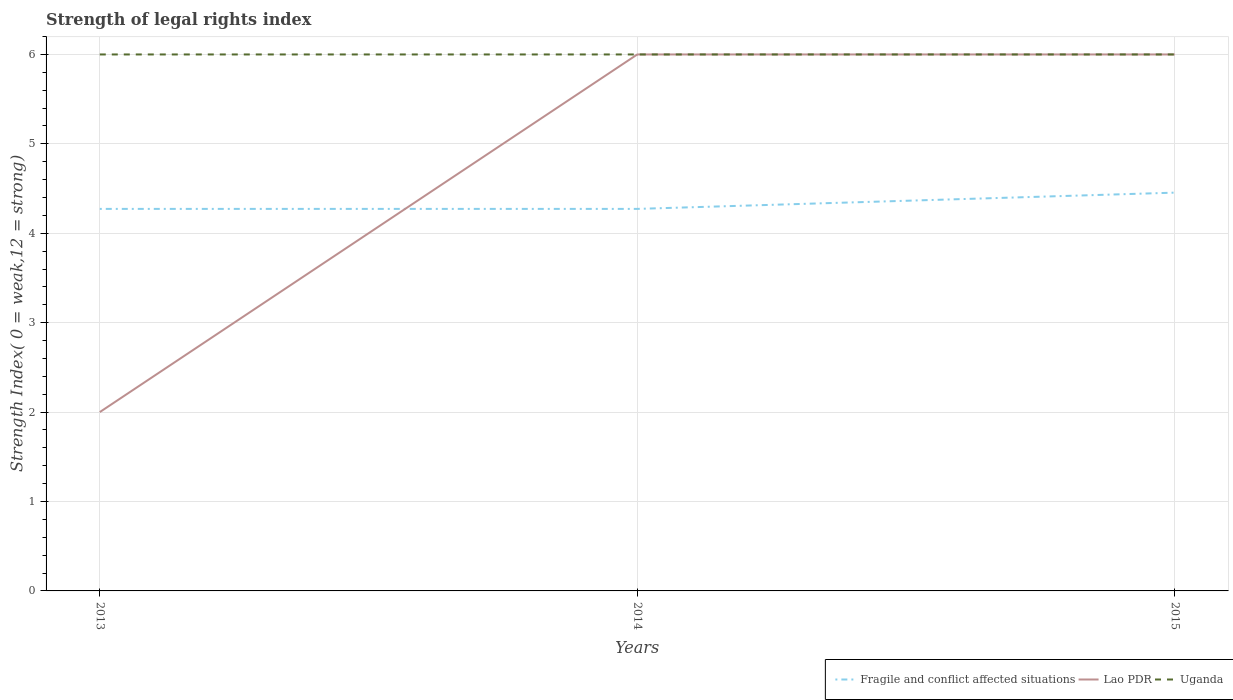Is the number of lines equal to the number of legend labels?
Your answer should be compact. Yes. Across all years, what is the maximum strength index in Fragile and conflict affected situations?
Your answer should be compact. 4.27. What is the difference between the highest and the second highest strength index in Lao PDR?
Ensure brevity in your answer.  4. What is the difference between the highest and the lowest strength index in Fragile and conflict affected situations?
Offer a very short reply. 1. How many legend labels are there?
Your answer should be very brief. 3. How are the legend labels stacked?
Provide a short and direct response. Horizontal. What is the title of the graph?
Offer a very short reply. Strength of legal rights index. What is the label or title of the Y-axis?
Make the answer very short. Strength Index( 0 = weak,12 = strong). What is the Strength Index( 0 = weak,12 = strong) of Fragile and conflict affected situations in 2013?
Make the answer very short. 4.27. What is the Strength Index( 0 = weak,12 = strong) in Fragile and conflict affected situations in 2014?
Offer a terse response. 4.27. What is the Strength Index( 0 = weak,12 = strong) in Lao PDR in 2014?
Keep it short and to the point. 6. What is the Strength Index( 0 = weak,12 = strong) of Fragile and conflict affected situations in 2015?
Offer a terse response. 4.45. Across all years, what is the maximum Strength Index( 0 = weak,12 = strong) of Fragile and conflict affected situations?
Offer a very short reply. 4.45. Across all years, what is the minimum Strength Index( 0 = weak,12 = strong) of Fragile and conflict affected situations?
Ensure brevity in your answer.  4.27. Across all years, what is the minimum Strength Index( 0 = weak,12 = strong) of Lao PDR?
Your answer should be compact. 2. Across all years, what is the minimum Strength Index( 0 = weak,12 = strong) in Uganda?
Ensure brevity in your answer.  6. What is the total Strength Index( 0 = weak,12 = strong) of Fragile and conflict affected situations in the graph?
Your answer should be very brief. 13. What is the difference between the Strength Index( 0 = weak,12 = strong) of Fragile and conflict affected situations in 2013 and that in 2014?
Provide a succinct answer. 0. What is the difference between the Strength Index( 0 = weak,12 = strong) of Uganda in 2013 and that in 2014?
Provide a short and direct response. 0. What is the difference between the Strength Index( 0 = weak,12 = strong) of Fragile and conflict affected situations in 2013 and that in 2015?
Provide a short and direct response. -0.18. What is the difference between the Strength Index( 0 = weak,12 = strong) of Lao PDR in 2013 and that in 2015?
Your answer should be compact. -4. What is the difference between the Strength Index( 0 = weak,12 = strong) of Uganda in 2013 and that in 2015?
Ensure brevity in your answer.  0. What is the difference between the Strength Index( 0 = weak,12 = strong) of Fragile and conflict affected situations in 2014 and that in 2015?
Ensure brevity in your answer.  -0.18. What is the difference between the Strength Index( 0 = weak,12 = strong) in Lao PDR in 2014 and that in 2015?
Your answer should be compact. 0. What is the difference between the Strength Index( 0 = weak,12 = strong) of Uganda in 2014 and that in 2015?
Give a very brief answer. 0. What is the difference between the Strength Index( 0 = weak,12 = strong) of Fragile and conflict affected situations in 2013 and the Strength Index( 0 = weak,12 = strong) of Lao PDR in 2014?
Ensure brevity in your answer.  -1.73. What is the difference between the Strength Index( 0 = weak,12 = strong) of Fragile and conflict affected situations in 2013 and the Strength Index( 0 = weak,12 = strong) of Uganda in 2014?
Your answer should be compact. -1.73. What is the difference between the Strength Index( 0 = weak,12 = strong) of Lao PDR in 2013 and the Strength Index( 0 = weak,12 = strong) of Uganda in 2014?
Provide a short and direct response. -4. What is the difference between the Strength Index( 0 = weak,12 = strong) in Fragile and conflict affected situations in 2013 and the Strength Index( 0 = weak,12 = strong) in Lao PDR in 2015?
Your answer should be compact. -1.73. What is the difference between the Strength Index( 0 = weak,12 = strong) of Fragile and conflict affected situations in 2013 and the Strength Index( 0 = weak,12 = strong) of Uganda in 2015?
Make the answer very short. -1.73. What is the difference between the Strength Index( 0 = weak,12 = strong) in Fragile and conflict affected situations in 2014 and the Strength Index( 0 = weak,12 = strong) in Lao PDR in 2015?
Offer a very short reply. -1.73. What is the difference between the Strength Index( 0 = weak,12 = strong) of Fragile and conflict affected situations in 2014 and the Strength Index( 0 = weak,12 = strong) of Uganda in 2015?
Offer a terse response. -1.73. What is the difference between the Strength Index( 0 = weak,12 = strong) in Lao PDR in 2014 and the Strength Index( 0 = weak,12 = strong) in Uganda in 2015?
Offer a terse response. 0. What is the average Strength Index( 0 = weak,12 = strong) in Fragile and conflict affected situations per year?
Offer a very short reply. 4.33. What is the average Strength Index( 0 = weak,12 = strong) of Lao PDR per year?
Ensure brevity in your answer.  4.67. What is the average Strength Index( 0 = weak,12 = strong) of Uganda per year?
Offer a terse response. 6. In the year 2013, what is the difference between the Strength Index( 0 = weak,12 = strong) of Fragile and conflict affected situations and Strength Index( 0 = weak,12 = strong) of Lao PDR?
Provide a short and direct response. 2.27. In the year 2013, what is the difference between the Strength Index( 0 = weak,12 = strong) in Fragile and conflict affected situations and Strength Index( 0 = weak,12 = strong) in Uganda?
Provide a succinct answer. -1.73. In the year 2013, what is the difference between the Strength Index( 0 = weak,12 = strong) of Lao PDR and Strength Index( 0 = weak,12 = strong) of Uganda?
Make the answer very short. -4. In the year 2014, what is the difference between the Strength Index( 0 = weak,12 = strong) of Fragile and conflict affected situations and Strength Index( 0 = weak,12 = strong) of Lao PDR?
Provide a short and direct response. -1.73. In the year 2014, what is the difference between the Strength Index( 0 = weak,12 = strong) in Fragile and conflict affected situations and Strength Index( 0 = weak,12 = strong) in Uganda?
Keep it short and to the point. -1.73. In the year 2014, what is the difference between the Strength Index( 0 = weak,12 = strong) in Lao PDR and Strength Index( 0 = weak,12 = strong) in Uganda?
Provide a succinct answer. 0. In the year 2015, what is the difference between the Strength Index( 0 = weak,12 = strong) of Fragile and conflict affected situations and Strength Index( 0 = weak,12 = strong) of Lao PDR?
Give a very brief answer. -1.55. In the year 2015, what is the difference between the Strength Index( 0 = weak,12 = strong) of Fragile and conflict affected situations and Strength Index( 0 = weak,12 = strong) of Uganda?
Offer a very short reply. -1.55. In the year 2015, what is the difference between the Strength Index( 0 = weak,12 = strong) in Lao PDR and Strength Index( 0 = weak,12 = strong) in Uganda?
Give a very brief answer. 0. What is the ratio of the Strength Index( 0 = weak,12 = strong) in Uganda in 2013 to that in 2014?
Offer a terse response. 1. What is the ratio of the Strength Index( 0 = weak,12 = strong) of Fragile and conflict affected situations in 2013 to that in 2015?
Provide a succinct answer. 0.96. What is the ratio of the Strength Index( 0 = weak,12 = strong) in Lao PDR in 2013 to that in 2015?
Provide a succinct answer. 0.33. What is the ratio of the Strength Index( 0 = weak,12 = strong) of Fragile and conflict affected situations in 2014 to that in 2015?
Make the answer very short. 0.96. What is the ratio of the Strength Index( 0 = weak,12 = strong) in Uganda in 2014 to that in 2015?
Provide a short and direct response. 1. What is the difference between the highest and the second highest Strength Index( 0 = weak,12 = strong) of Fragile and conflict affected situations?
Your answer should be compact. 0.18. What is the difference between the highest and the lowest Strength Index( 0 = weak,12 = strong) in Fragile and conflict affected situations?
Keep it short and to the point. 0.18. What is the difference between the highest and the lowest Strength Index( 0 = weak,12 = strong) of Lao PDR?
Make the answer very short. 4. What is the difference between the highest and the lowest Strength Index( 0 = weak,12 = strong) in Uganda?
Make the answer very short. 0. 